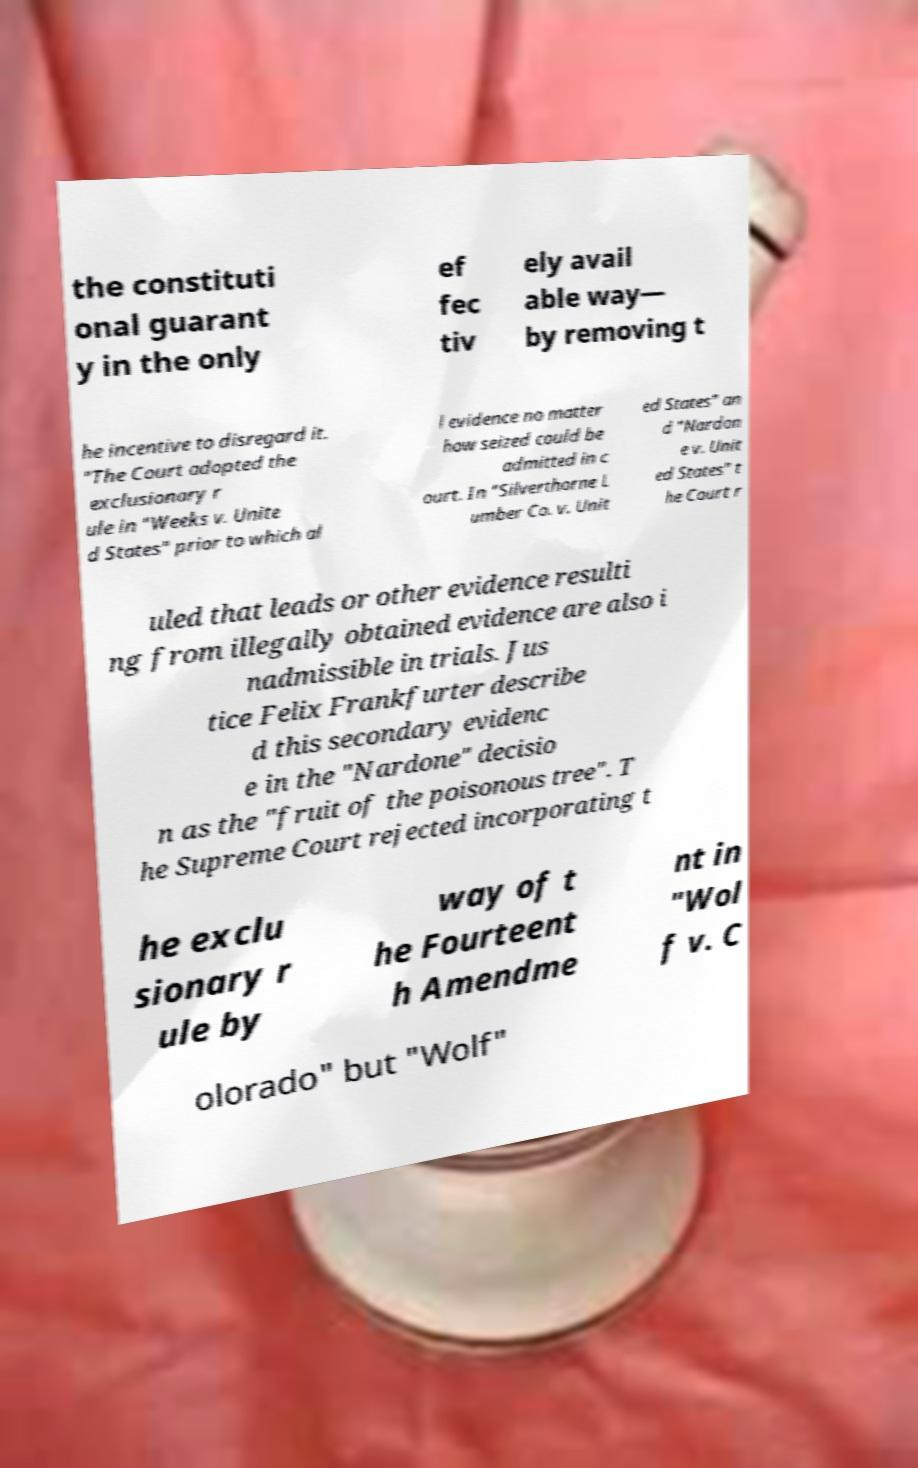Could you extract and type out the text from this image? the constituti onal guarant y in the only ef fec tiv ely avail able way— by removing t he incentive to disregard it. "The Court adopted the exclusionary r ule in "Weeks v. Unite d States" prior to which al l evidence no matter how seized could be admitted in c ourt. In "Silverthorne L umber Co. v. Unit ed States" an d "Nardon e v. Unit ed States" t he Court r uled that leads or other evidence resulti ng from illegally obtained evidence are also i nadmissible in trials. Jus tice Felix Frankfurter describe d this secondary evidenc e in the "Nardone" decisio n as the "fruit of the poisonous tree". T he Supreme Court rejected incorporating t he exclu sionary r ule by way of t he Fourteent h Amendme nt in "Wol f v. C olorado" but "Wolf" 